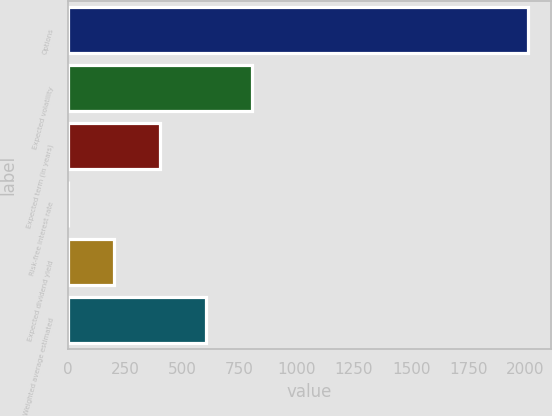Convert chart. <chart><loc_0><loc_0><loc_500><loc_500><bar_chart><fcel>Options<fcel>Expected volatility<fcel>Expected term (in years)<fcel>Risk-free interest rate<fcel>Expected dividend yield<fcel>Weighted average estimated<nl><fcel>2012<fcel>805.46<fcel>403.28<fcel>1.1<fcel>202.19<fcel>604.37<nl></chart> 